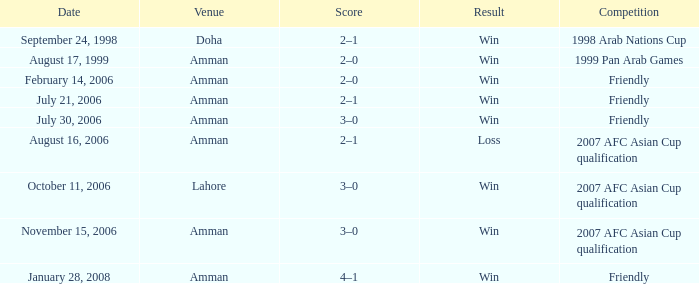Parse the table in full. {'header': ['Date', 'Venue', 'Score', 'Result', 'Competition'], 'rows': [['September 24, 1998', 'Doha', '2–1', 'Win', '1998 Arab Nations Cup'], ['August 17, 1999', 'Amman', '2–0', 'Win', '1999 Pan Arab Games'], ['February 14, 2006', 'Amman', '2–0', 'Win', 'Friendly'], ['July 21, 2006', 'Amman', '2–1', 'Win', 'Friendly'], ['July 30, 2006', 'Amman', '3–0', 'Win', 'Friendly'], ['August 16, 2006', 'Amman', '2–1', 'Loss', '2007 AFC Asian Cup qualification'], ['October 11, 2006', 'Lahore', '3–0', 'Win', '2007 AFC Asian Cup qualification'], ['November 15, 2006', 'Amman', '3–0', 'Win', '2007 AFC Asian Cup qualification'], ['January 28, 2008', 'Amman', '4–1', 'Win', 'Friendly']]} At what location did ra'fat ali play on august 17, 1999? Amman. 